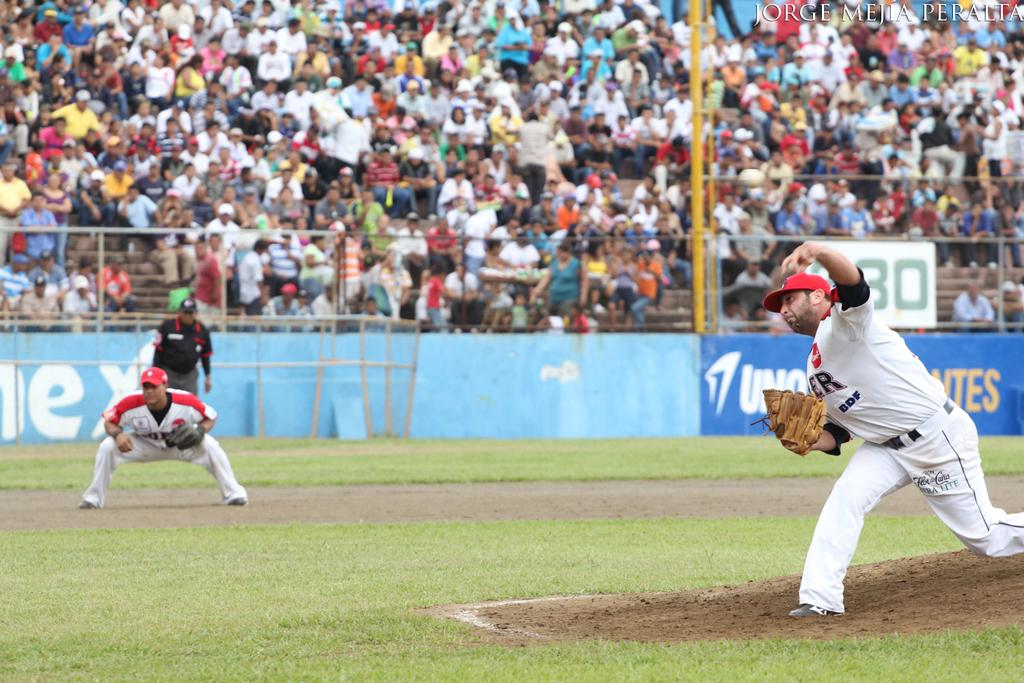Provide a one-sentence caption for the provided image. Ultra Lite reads the sponsor on the pants of the pitcher. 